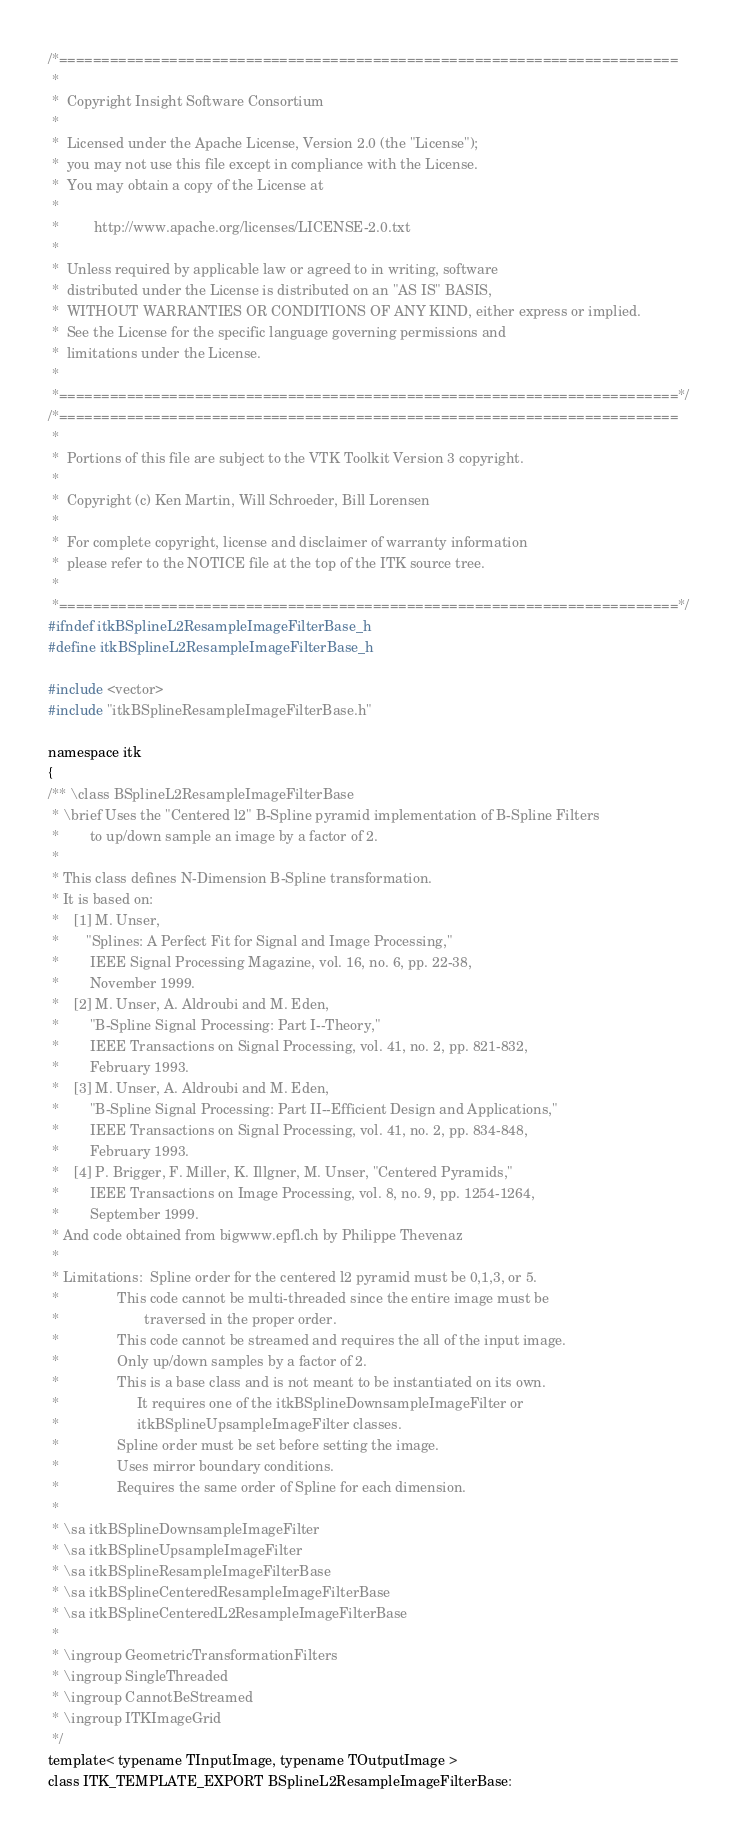Convert code to text. <code><loc_0><loc_0><loc_500><loc_500><_C_>/*=========================================================================
 *
 *  Copyright Insight Software Consortium
 *
 *  Licensed under the Apache License, Version 2.0 (the "License");
 *  you may not use this file except in compliance with the License.
 *  You may obtain a copy of the License at
 *
 *         http://www.apache.org/licenses/LICENSE-2.0.txt
 *
 *  Unless required by applicable law or agreed to in writing, software
 *  distributed under the License is distributed on an "AS IS" BASIS,
 *  WITHOUT WARRANTIES OR CONDITIONS OF ANY KIND, either express or implied.
 *  See the License for the specific language governing permissions and
 *  limitations under the License.
 *
 *=========================================================================*/
/*=========================================================================
 *
 *  Portions of this file are subject to the VTK Toolkit Version 3 copyright.
 *
 *  Copyright (c) Ken Martin, Will Schroeder, Bill Lorensen
 *
 *  For complete copyright, license and disclaimer of warranty information
 *  please refer to the NOTICE file at the top of the ITK source tree.
 *
 *=========================================================================*/
#ifndef itkBSplineL2ResampleImageFilterBase_h
#define itkBSplineL2ResampleImageFilterBase_h

#include <vector>
#include "itkBSplineResampleImageFilterBase.h"

namespace itk
{
/** \class BSplineL2ResampleImageFilterBase
 * \brief Uses the "Centered l2" B-Spline pyramid implementation of B-Spline Filters
 *        to up/down sample an image by a factor of 2.
 *
 * This class defines N-Dimension B-Spline transformation.
 * It is based on:
 *    [1] M. Unser,
 *       "Splines: A Perfect Fit for Signal and Image Processing,"
 *        IEEE Signal Processing Magazine, vol. 16, no. 6, pp. 22-38,
 *        November 1999.
 *    [2] M. Unser, A. Aldroubi and M. Eden,
 *        "B-Spline Signal Processing: Part I--Theory,"
 *        IEEE Transactions on Signal Processing, vol. 41, no. 2, pp. 821-832,
 *        February 1993.
 *    [3] M. Unser, A. Aldroubi and M. Eden,
 *        "B-Spline Signal Processing: Part II--Efficient Design and Applications,"
 *        IEEE Transactions on Signal Processing, vol. 41, no. 2, pp. 834-848,
 *        February 1993.
 *    [4] P. Brigger, F. Miller, K. Illgner, M. Unser, "Centered Pyramids,"
 *        IEEE Transactions on Image Processing, vol. 8, no. 9, pp. 1254-1264,
 *        September 1999.
 * And code obtained from bigwww.epfl.ch by Philippe Thevenaz
 *
 * Limitations:  Spline order for the centered l2 pyramid must be 0,1,3, or 5.
 *               This code cannot be multi-threaded since the entire image must be
 *                      traversed in the proper order.
 *               This code cannot be streamed and requires the all of the input image.
 *               Only up/down samples by a factor of 2.
 *               This is a base class and is not meant to be instantiated on its own.
 *                    It requires one of the itkBSplineDownsampleImageFilter or
 *                    itkBSplineUpsampleImageFilter classes.
 *               Spline order must be set before setting the image.
 *               Uses mirror boundary conditions.
 *               Requires the same order of Spline for each dimension.
 *
 * \sa itkBSplineDownsampleImageFilter
 * \sa itkBSplineUpsampleImageFilter
 * \sa itkBSplineResampleImageFilterBase
 * \sa itkBSplineCenteredResampleImageFilterBase
 * \sa itkBSplineCenteredL2ResampleImageFilterBase
 *
 * \ingroup GeometricTransformationFilters
 * \ingroup SingleThreaded
 * \ingroup CannotBeStreamed
 * \ingroup ITKImageGrid
 */
template< typename TInputImage, typename TOutputImage >
class ITK_TEMPLATE_EXPORT BSplineL2ResampleImageFilterBase:</code> 